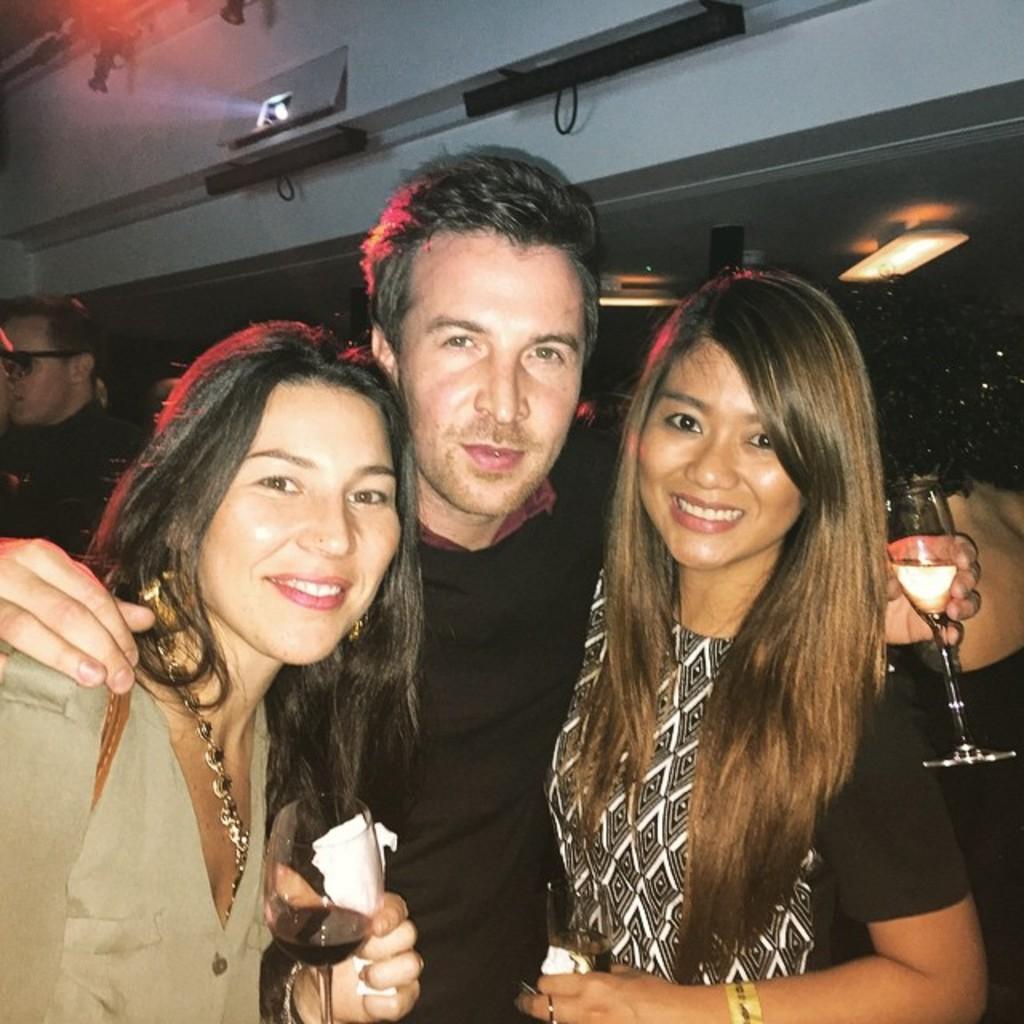How would you summarize this image in a sentence or two? In this image i can see 2 women and a man standing and holding wine glasses in their hands. In the background i can see a man, projector and few lights. 